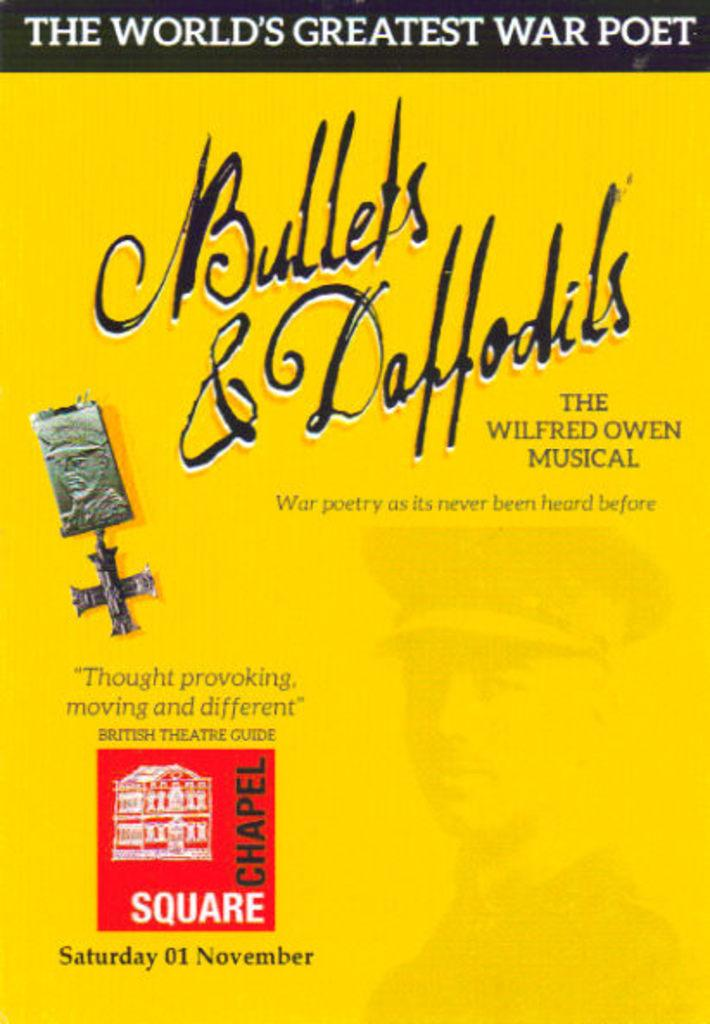<image>
Give a short and clear explanation of the subsequent image. A flyer for the musical Bullets & Daffodils shows that it will be held Saturday November 1st. 